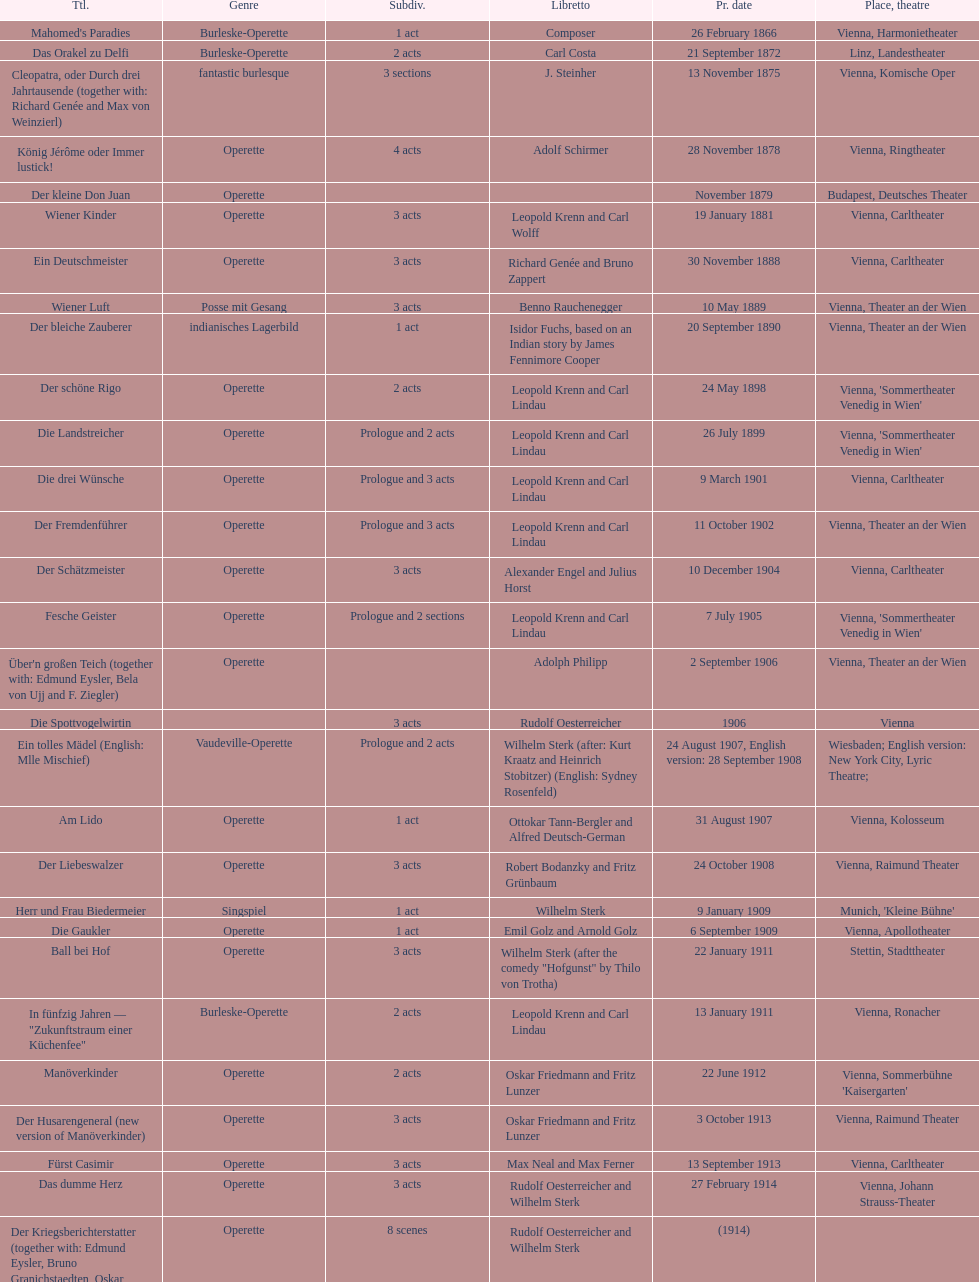What are the number of titles that premiered in the month of september? 4. 